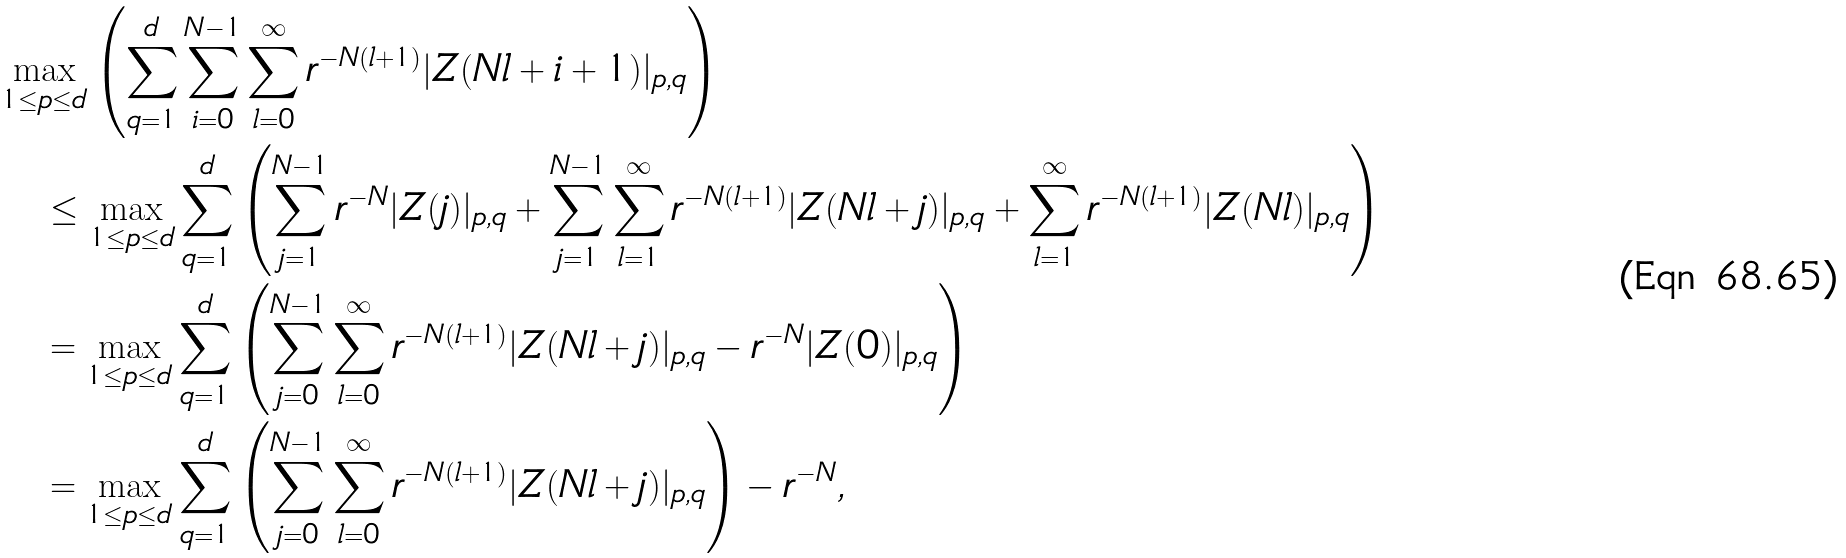Convert formula to latex. <formula><loc_0><loc_0><loc_500><loc_500>& \max _ { 1 \leq p \leq d } \left ( \sum _ { q = 1 } ^ { d } \sum _ { i = 0 } ^ { N - 1 } \sum _ { l = 0 } ^ { \infty } r ^ { - N ( l + 1 ) } | Z ( N l + i + 1 ) | _ { p , q } \right ) \\ & \quad \leq \max _ { 1 \leq p \leq d } \sum _ { q = 1 } ^ { d } \left ( \sum _ { j = 1 } ^ { N - 1 } r ^ { - N } | Z ( j ) | _ { p , q } + \sum _ { j = 1 } ^ { N - 1 } \sum _ { l = 1 } ^ { \infty } r ^ { - N ( l + 1 ) } | Z ( N l + j ) | _ { p , q } + \sum _ { l = 1 } ^ { \infty } r ^ { - N ( l + 1 ) } | Z ( N l ) | _ { p , q } \right ) \\ & \quad = \max _ { 1 \leq p \leq d } \sum _ { q = 1 } ^ { d } \left ( \sum _ { j = 0 } ^ { N - 1 } \sum _ { l = 0 } ^ { \infty } r ^ { - N ( l + 1 ) } | Z ( N l + j ) | _ { p , q } - r ^ { - N } | Z ( 0 ) | _ { p , q } \right ) \\ & \quad = \max _ { 1 \leq p \leq d } \sum _ { q = 1 } ^ { d } \left ( \sum _ { j = 0 } ^ { N - 1 } \sum _ { l = 0 } ^ { \infty } r ^ { - N ( l + 1 ) } | Z ( N l + j ) | _ { p , q } \right ) - r ^ { - N } ,</formula> 